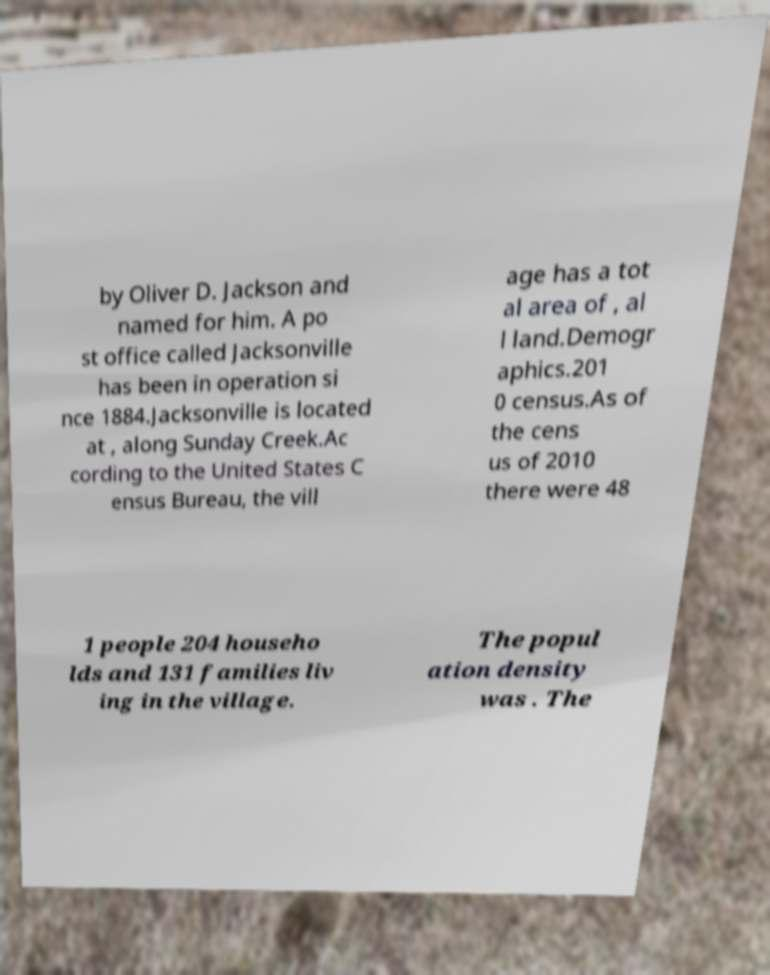Could you assist in decoding the text presented in this image and type it out clearly? by Oliver D. Jackson and named for him. A po st office called Jacksonville has been in operation si nce 1884.Jacksonville is located at , along Sunday Creek.Ac cording to the United States C ensus Bureau, the vill age has a tot al area of , al l land.Demogr aphics.201 0 census.As of the cens us of 2010 there were 48 1 people 204 househo lds and 131 families liv ing in the village. The popul ation density was . The 